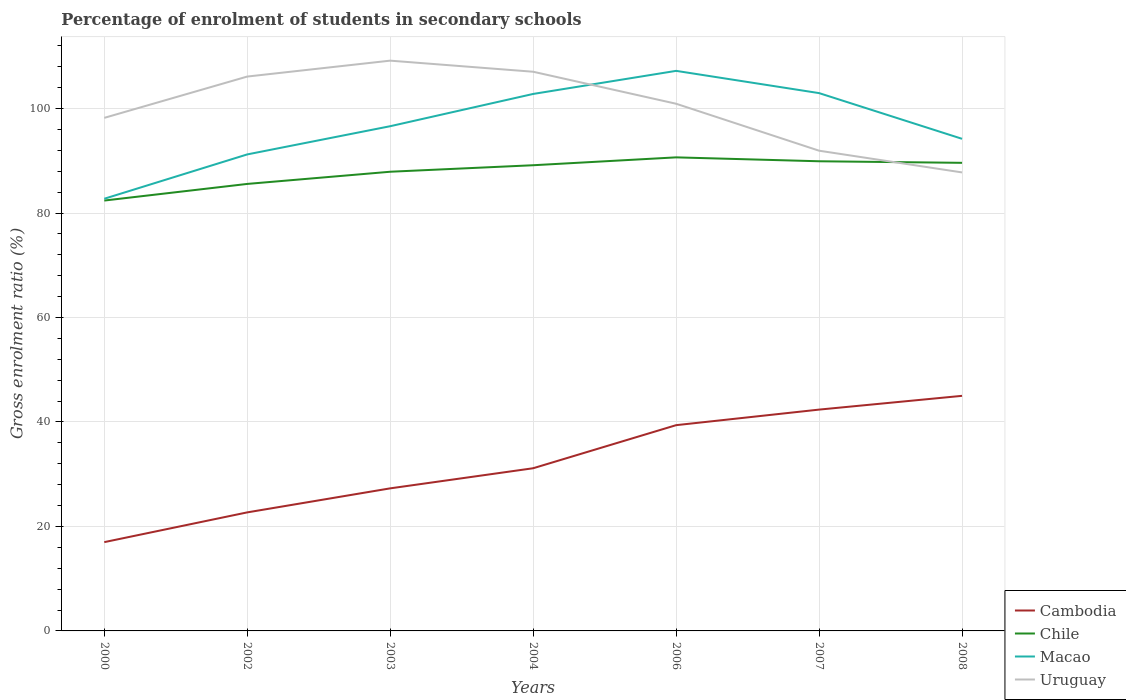Does the line corresponding to Cambodia intersect with the line corresponding to Chile?
Offer a terse response. No. Across all years, what is the maximum percentage of students enrolled in secondary schools in Uruguay?
Offer a terse response. 87.78. What is the total percentage of students enrolled in secondary schools in Uruguay in the graph?
Provide a succinct answer. 19.27. What is the difference between the highest and the second highest percentage of students enrolled in secondary schools in Cambodia?
Offer a very short reply. 28.01. Is the percentage of students enrolled in secondary schools in Macao strictly greater than the percentage of students enrolled in secondary schools in Uruguay over the years?
Your response must be concise. No. How many legend labels are there?
Your response must be concise. 4. How are the legend labels stacked?
Provide a succinct answer. Vertical. What is the title of the graph?
Your response must be concise. Percentage of enrolment of students in secondary schools. Does "Macedonia" appear as one of the legend labels in the graph?
Make the answer very short. No. What is the label or title of the Y-axis?
Make the answer very short. Gross enrolment ratio (%). What is the Gross enrolment ratio (%) in Cambodia in 2000?
Provide a succinct answer. 17. What is the Gross enrolment ratio (%) of Chile in 2000?
Make the answer very short. 82.39. What is the Gross enrolment ratio (%) of Macao in 2000?
Your answer should be compact. 82.74. What is the Gross enrolment ratio (%) of Uruguay in 2000?
Your answer should be compact. 98.22. What is the Gross enrolment ratio (%) in Cambodia in 2002?
Your answer should be very brief. 22.69. What is the Gross enrolment ratio (%) of Chile in 2002?
Provide a short and direct response. 85.58. What is the Gross enrolment ratio (%) of Macao in 2002?
Offer a terse response. 91.23. What is the Gross enrolment ratio (%) of Uruguay in 2002?
Provide a succinct answer. 106.13. What is the Gross enrolment ratio (%) of Cambodia in 2003?
Offer a terse response. 27.29. What is the Gross enrolment ratio (%) of Chile in 2003?
Offer a very short reply. 87.91. What is the Gross enrolment ratio (%) of Macao in 2003?
Make the answer very short. 96.63. What is the Gross enrolment ratio (%) in Uruguay in 2003?
Provide a short and direct response. 109.18. What is the Gross enrolment ratio (%) in Cambodia in 2004?
Your response must be concise. 31.14. What is the Gross enrolment ratio (%) in Chile in 2004?
Provide a succinct answer. 89.15. What is the Gross enrolment ratio (%) in Macao in 2004?
Your answer should be compact. 102.8. What is the Gross enrolment ratio (%) in Uruguay in 2004?
Offer a terse response. 107.05. What is the Gross enrolment ratio (%) of Cambodia in 2006?
Ensure brevity in your answer.  39.39. What is the Gross enrolment ratio (%) of Chile in 2006?
Make the answer very short. 90.66. What is the Gross enrolment ratio (%) in Macao in 2006?
Keep it short and to the point. 107.22. What is the Gross enrolment ratio (%) in Uruguay in 2006?
Ensure brevity in your answer.  100.93. What is the Gross enrolment ratio (%) of Cambodia in 2007?
Provide a succinct answer. 42.37. What is the Gross enrolment ratio (%) of Chile in 2007?
Provide a succinct answer. 89.91. What is the Gross enrolment ratio (%) in Macao in 2007?
Keep it short and to the point. 102.96. What is the Gross enrolment ratio (%) of Uruguay in 2007?
Offer a terse response. 91.94. What is the Gross enrolment ratio (%) of Cambodia in 2008?
Your answer should be very brief. 45.01. What is the Gross enrolment ratio (%) of Chile in 2008?
Your answer should be compact. 89.62. What is the Gross enrolment ratio (%) in Macao in 2008?
Ensure brevity in your answer.  94.21. What is the Gross enrolment ratio (%) in Uruguay in 2008?
Your response must be concise. 87.78. Across all years, what is the maximum Gross enrolment ratio (%) in Cambodia?
Provide a succinct answer. 45.01. Across all years, what is the maximum Gross enrolment ratio (%) in Chile?
Your answer should be compact. 90.66. Across all years, what is the maximum Gross enrolment ratio (%) of Macao?
Offer a terse response. 107.22. Across all years, what is the maximum Gross enrolment ratio (%) in Uruguay?
Make the answer very short. 109.18. Across all years, what is the minimum Gross enrolment ratio (%) in Cambodia?
Provide a succinct answer. 17. Across all years, what is the minimum Gross enrolment ratio (%) in Chile?
Offer a terse response. 82.39. Across all years, what is the minimum Gross enrolment ratio (%) in Macao?
Give a very brief answer. 82.74. Across all years, what is the minimum Gross enrolment ratio (%) of Uruguay?
Provide a succinct answer. 87.78. What is the total Gross enrolment ratio (%) in Cambodia in the graph?
Give a very brief answer. 224.9. What is the total Gross enrolment ratio (%) of Chile in the graph?
Offer a very short reply. 615.23. What is the total Gross enrolment ratio (%) in Macao in the graph?
Keep it short and to the point. 677.79. What is the total Gross enrolment ratio (%) in Uruguay in the graph?
Your response must be concise. 701.23. What is the difference between the Gross enrolment ratio (%) of Cambodia in 2000 and that in 2002?
Make the answer very short. -5.7. What is the difference between the Gross enrolment ratio (%) in Chile in 2000 and that in 2002?
Make the answer very short. -3.18. What is the difference between the Gross enrolment ratio (%) of Macao in 2000 and that in 2002?
Offer a terse response. -8.49. What is the difference between the Gross enrolment ratio (%) in Uruguay in 2000 and that in 2002?
Provide a succinct answer. -7.91. What is the difference between the Gross enrolment ratio (%) of Cambodia in 2000 and that in 2003?
Provide a short and direct response. -10.3. What is the difference between the Gross enrolment ratio (%) in Chile in 2000 and that in 2003?
Give a very brief answer. -5.51. What is the difference between the Gross enrolment ratio (%) of Macao in 2000 and that in 2003?
Keep it short and to the point. -13.89. What is the difference between the Gross enrolment ratio (%) of Uruguay in 2000 and that in 2003?
Give a very brief answer. -10.95. What is the difference between the Gross enrolment ratio (%) in Cambodia in 2000 and that in 2004?
Offer a very short reply. -14.15. What is the difference between the Gross enrolment ratio (%) of Chile in 2000 and that in 2004?
Your response must be concise. -6.76. What is the difference between the Gross enrolment ratio (%) of Macao in 2000 and that in 2004?
Your response must be concise. -20.07. What is the difference between the Gross enrolment ratio (%) in Uruguay in 2000 and that in 2004?
Provide a succinct answer. -8.83. What is the difference between the Gross enrolment ratio (%) of Cambodia in 2000 and that in 2006?
Offer a very short reply. -22.39. What is the difference between the Gross enrolment ratio (%) of Chile in 2000 and that in 2006?
Provide a short and direct response. -8.27. What is the difference between the Gross enrolment ratio (%) in Macao in 2000 and that in 2006?
Provide a short and direct response. -24.48. What is the difference between the Gross enrolment ratio (%) of Uruguay in 2000 and that in 2006?
Keep it short and to the point. -2.7. What is the difference between the Gross enrolment ratio (%) of Cambodia in 2000 and that in 2007?
Offer a very short reply. -25.37. What is the difference between the Gross enrolment ratio (%) of Chile in 2000 and that in 2007?
Offer a very short reply. -7.52. What is the difference between the Gross enrolment ratio (%) of Macao in 2000 and that in 2007?
Your answer should be very brief. -20.23. What is the difference between the Gross enrolment ratio (%) of Uruguay in 2000 and that in 2007?
Make the answer very short. 6.29. What is the difference between the Gross enrolment ratio (%) in Cambodia in 2000 and that in 2008?
Your answer should be very brief. -28.01. What is the difference between the Gross enrolment ratio (%) in Chile in 2000 and that in 2008?
Make the answer very short. -7.22. What is the difference between the Gross enrolment ratio (%) of Macao in 2000 and that in 2008?
Your answer should be very brief. -11.48. What is the difference between the Gross enrolment ratio (%) of Uruguay in 2000 and that in 2008?
Provide a short and direct response. 10.44. What is the difference between the Gross enrolment ratio (%) of Cambodia in 2002 and that in 2003?
Provide a succinct answer. -4.6. What is the difference between the Gross enrolment ratio (%) of Chile in 2002 and that in 2003?
Offer a terse response. -2.33. What is the difference between the Gross enrolment ratio (%) of Macao in 2002 and that in 2003?
Ensure brevity in your answer.  -5.4. What is the difference between the Gross enrolment ratio (%) of Uruguay in 2002 and that in 2003?
Offer a very short reply. -3.04. What is the difference between the Gross enrolment ratio (%) of Cambodia in 2002 and that in 2004?
Keep it short and to the point. -8.45. What is the difference between the Gross enrolment ratio (%) in Chile in 2002 and that in 2004?
Your answer should be compact. -3.58. What is the difference between the Gross enrolment ratio (%) in Macao in 2002 and that in 2004?
Your answer should be very brief. -11.58. What is the difference between the Gross enrolment ratio (%) in Uruguay in 2002 and that in 2004?
Your response must be concise. -0.92. What is the difference between the Gross enrolment ratio (%) of Cambodia in 2002 and that in 2006?
Offer a terse response. -16.7. What is the difference between the Gross enrolment ratio (%) in Chile in 2002 and that in 2006?
Give a very brief answer. -5.09. What is the difference between the Gross enrolment ratio (%) of Macao in 2002 and that in 2006?
Offer a very short reply. -16. What is the difference between the Gross enrolment ratio (%) of Uruguay in 2002 and that in 2006?
Offer a terse response. 5.21. What is the difference between the Gross enrolment ratio (%) of Cambodia in 2002 and that in 2007?
Offer a very short reply. -19.68. What is the difference between the Gross enrolment ratio (%) of Chile in 2002 and that in 2007?
Offer a terse response. -4.34. What is the difference between the Gross enrolment ratio (%) of Macao in 2002 and that in 2007?
Make the answer very short. -11.74. What is the difference between the Gross enrolment ratio (%) of Uruguay in 2002 and that in 2007?
Make the answer very short. 14.2. What is the difference between the Gross enrolment ratio (%) of Cambodia in 2002 and that in 2008?
Ensure brevity in your answer.  -22.31. What is the difference between the Gross enrolment ratio (%) in Chile in 2002 and that in 2008?
Your answer should be compact. -4.04. What is the difference between the Gross enrolment ratio (%) in Macao in 2002 and that in 2008?
Your answer should be compact. -2.99. What is the difference between the Gross enrolment ratio (%) in Uruguay in 2002 and that in 2008?
Give a very brief answer. 18.35. What is the difference between the Gross enrolment ratio (%) of Cambodia in 2003 and that in 2004?
Give a very brief answer. -3.85. What is the difference between the Gross enrolment ratio (%) in Chile in 2003 and that in 2004?
Offer a very short reply. -1.24. What is the difference between the Gross enrolment ratio (%) of Macao in 2003 and that in 2004?
Your answer should be compact. -6.18. What is the difference between the Gross enrolment ratio (%) of Uruguay in 2003 and that in 2004?
Your response must be concise. 2.12. What is the difference between the Gross enrolment ratio (%) in Cambodia in 2003 and that in 2006?
Provide a succinct answer. -12.1. What is the difference between the Gross enrolment ratio (%) in Chile in 2003 and that in 2006?
Make the answer very short. -2.75. What is the difference between the Gross enrolment ratio (%) of Macao in 2003 and that in 2006?
Keep it short and to the point. -10.6. What is the difference between the Gross enrolment ratio (%) in Uruguay in 2003 and that in 2006?
Your answer should be very brief. 8.25. What is the difference between the Gross enrolment ratio (%) in Cambodia in 2003 and that in 2007?
Your response must be concise. -15.08. What is the difference between the Gross enrolment ratio (%) of Chile in 2003 and that in 2007?
Your answer should be very brief. -2. What is the difference between the Gross enrolment ratio (%) in Macao in 2003 and that in 2007?
Your answer should be compact. -6.34. What is the difference between the Gross enrolment ratio (%) of Uruguay in 2003 and that in 2007?
Offer a very short reply. 17.24. What is the difference between the Gross enrolment ratio (%) in Cambodia in 2003 and that in 2008?
Your answer should be compact. -17.71. What is the difference between the Gross enrolment ratio (%) of Chile in 2003 and that in 2008?
Your answer should be very brief. -1.71. What is the difference between the Gross enrolment ratio (%) of Macao in 2003 and that in 2008?
Keep it short and to the point. 2.41. What is the difference between the Gross enrolment ratio (%) of Uruguay in 2003 and that in 2008?
Offer a very short reply. 21.4. What is the difference between the Gross enrolment ratio (%) of Cambodia in 2004 and that in 2006?
Provide a short and direct response. -8.25. What is the difference between the Gross enrolment ratio (%) of Chile in 2004 and that in 2006?
Your answer should be compact. -1.51. What is the difference between the Gross enrolment ratio (%) of Macao in 2004 and that in 2006?
Your response must be concise. -4.42. What is the difference between the Gross enrolment ratio (%) of Uruguay in 2004 and that in 2006?
Ensure brevity in your answer.  6.13. What is the difference between the Gross enrolment ratio (%) in Cambodia in 2004 and that in 2007?
Make the answer very short. -11.23. What is the difference between the Gross enrolment ratio (%) in Chile in 2004 and that in 2007?
Make the answer very short. -0.76. What is the difference between the Gross enrolment ratio (%) of Macao in 2004 and that in 2007?
Offer a very short reply. -0.16. What is the difference between the Gross enrolment ratio (%) of Uruguay in 2004 and that in 2007?
Give a very brief answer. 15.12. What is the difference between the Gross enrolment ratio (%) of Cambodia in 2004 and that in 2008?
Keep it short and to the point. -13.86. What is the difference between the Gross enrolment ratio (%) in Chile in 2004 and that in 2008?
Your answer should be compact. -0.46. What is the difference between the Gross enrolment ratio (%) of Macao in 2004 and that in 2008?
Your answer should be very brief. 8.59. What is the difference between the Gross enrolment ratio (%) of Uruguay in 2004 and that in 2008?
Your response must be concise. 19.27. What is the difference between the Gross enrolment ratio (%) in Cambodia in 2006 and that in 2007?
Offer a terse response. -2.98. What is the difference between the Gross enrolment ratio (%) in Chile in 2006 and that in 2007?
Keep it short and to the point. 0.75. What is the difference between the Gross enrolment ratio (%) in Macao in 2006 and that in 2007?
Your answer should be compact. 4.26. What is the difference between the Gross enrolment ratio (%) of Uruguay in 2006 and that in 2007?
Keep it short and to the point. 8.99. What is the difference between the Gross enrolment ratio (%) in Cambodia in 2006 and that in 2008?
Make the answer very short. -5.62. What is the difference between the Gross enrolment ratio (%) in Chile in 2006 and that in 2008?
Make the answer very short. 1.05. What is the difference between the Gross enrolment ratio (%) of Macao in 2006 and that in 2008?
Your response must be concise. 13.01. What is the difference between the Gross enrolment ratio (%) in Uruguay in 2006 and that in 2008?
Give a very brief answer. 13.15. What is the difference between the Gross enrolment ratio (%) of Cambodia in 2007 and that in 2008?
Offer a very short reply. -2.64. What is the difference between the Gross enrolment ratio (%) in Chile in 2007 and that in 2008?
Offer a very short reply. 0.3. What is the difference between the Gross enrolment ratio (%) of Macao in 2007 and that in 2008?
Offer a very short reply. 8.75. What is the difference between the Gross enrolment ratio (%) in Uruguay in 2007 and that in 2008?
Provide a short and direct response. 4.16. What is the difference between the Gross enrolment ratio (%) in Cambodia in 2000 and the Gross enrolment ratio (%) in Chile in 2002?
Offer a very short reply. -68.58. What is the difference between the Gross enrolment ratio (%) of Cambodia in 2000 and the Gross enrolment ratio (%) of Macao in 2002?
Make the answer very short. -74.23. What is the difference between the Gross enrolment ratio (%) in Cambodia in 2000 and the Gross enrolment ratio (%) in Uruguay in 2002?
Your answer should be very brief. -89.13. What is the difference between the Gross enrolment ratio (%) in Chile in 2000 and the Gross enrolment ratio (%) in Macao in 2002?
Provide a succinct answer. -8.83. What is the difference between the Gross enrolment ratio (%) of Chile in 2000 and the Gross enrolment ratio (%) of Uruguay in 2002?
Give a very brief answer. -23.74. What is the difference between the Gross enrolment ratio (%) of Macao in 2000 and the Gross enrolment ratio (%) of Uruguay in 2002?
Offer a terse response. -23.4. What is the difference between the Gross enrolment ratio (%) in Cambodia in 2000 and the Gross enrolment ratio (%) in Chile in 2003?
Provide a succinct answer. -70.91. What is the difference between the Gross enrolment ratio (%) in Cambodia in 2000 and the Gross enrolment ratio (%) in Macao in 2003?
Give a very brief answer. -79.63. What is the difference between the Gross enrolment ratio (%) of Cambodia in 2000 and the Gross enrolment ratio (%) of Uruguay in 2003?
Ensure brevity in your answer.  -92.18. What is the difference between the Gross enrolment ratio (%) in Chile in 2000 and the Gross enrolment ratio (%) in Macao in 2003?
Your answer should be very brief. -14.23. What is the difference between the Gross enrolment ratio (%) in Chile in 2000 and the Gross enrolment ratio (%) in Uruguay in 2003?
Give a very brief answer. -26.78. What is the difference between the Gross enrolment ratio (%) in Macao in 2000 and the Gross enrolment ratio (%) in Uruguay in 2003?
Keep it short and to the point. -26.44. What is the difference between the Gross enrolment ratio (%) of Cambodia in 2000 and the Gross enrolment ratio (%) of Chile in 2004?
Give a very brief answer. -72.16. What is the difference between the Gross enrolment ratio (%) of Cambodia in 2000 and the Gross enrolment ratio (%) of Macao in 2004?
Offer a terse response. -85.8. What is the difference between the Gross enrolment ratio (%) of Cambodia in 2000 and the Gross enrolment ratio (%) of Uruguay in 2004?
Your response must be concise. -90.06. What is the difference between the Gross enrolment ratio (%) of Chile in 2000 and the Gross enrolment ratio (%) of Macao in 2004?
Make the answer very short. -20.41. What is the difference between the Gross enrolment ratio (%) in Chile in 2000 and the Gross enrolment ratio (%) in Uruguay in 2004?
Your answer should be very brief. -24.66. What is the difference between the Gross enrolment ratio (%) in Macao in 2000 and the Gross enrolment ratio (%) in Uruguay in 2004?
Your answer should be compact. -24.32. What is the difference between the Gross enrolment ratio (%) of Cambodia in 2000 and the Gross enrolment ratio (%) of Chile in 2006?
Give a very brief answer. -73.66. What is the difference between the Gross enrolment ratio (%) in Cambodia in 2000 and the Gross enrolment ratio (%) in Macao in 2006?
Your answer should be compact. -90.22. What is the difference between the Gross enrolment ratio (%) in Cambodia in 2000 and the Gross enrolment ratio (%) in Uruguay in 2006?
Offer a very short reply. -83.93. What is the difference between the Gross enrolment ratio (%) in Chile in 2000 and the Gross enrolment ratio (%) in Macao in 2006?
Make the answer very short. -24.83. What is the difference between the Gross enrolment ratio (%) of Chile in 2000 and the Gross enrolment ratio (%) of Uruguay in 2006?
Your answer should be very brief. -18.53. What is the difference between the Gross enrolment ratio (%) in Macao in 2000 and the Gross enrolment ratio (%) in Uruguay in 2006?
Provide a short and direct response. -18.19. What is the difference between the Gross enrolment ratio (%) in Cambodia in 2000 and the Gross enrolment ratio (%) in Chile in 2007?
Provide a short and direct response. -72.92. What is the difference between the Gross enrolment ratio (%) in Cambodia in 2000 and the Gross enrolment ratio (%) in Macao in 2007?
Keep it short and to the point. -85.97. What is the difference between the Gross enrolment ratio (%) in Cambodia in 2000 and the Gross enrolment ratio (%) in Uruguay in 2007?
Your answer should be compact. -74.94. What is the difference between the Gross enrolment ratio (%) of Chile in 2000 and the Gross enrolment ratio (%) of Macao in 2007?
Provide a succinct answer. -20.57. What is the difference between the Gross enrolment ratio (%) in Chile in 2000 and the Gross enrolment ratio (%) in Uruguay in 2007?
Make the answer very short. -9.54. What is the difference between the Gross enrolment ratio (%) in Macao in 2000 and the Gross enrolment ratio (%) in Uruguay in 2007?
Make the answer very short. -9.2. What is the difference between the Gross enrolment ratio (%) in Cambodia in 2000 and the Gross enrolment ratio (%) in Chile in 2008?
Your answer should be very brief. -72.62. What is the difference between the Gross enrolment ratio (%) of Cambodia in 2000 and the Gross enrolment ratio (%) of Macao in 2008?
Make the answer very short. -77.22. What is the difference between the Gross enrolment ratio (%) of Cambodia in 2000 and the Gross enrolment ratio (%) of Uruguay in 2008?
Make the answer very short. -70.78. What is the difference between the Gross enrolment ratio (%) in Chile in 2000 and the Gross enrolment ratio (%) in Macao in 2008?
Your answer should be very brief. -11.82. What is the difference between the Gross enrolment ratio (%) in Chile in 2000 and the Gross enrolment ratio (%) in Uruguay in 2008?
Provide a short and direct response. -5.38. What is the difference between the Gross enrolment ratio (%) in Macao in 2000 and the Gross enrolment ratio (%) in Uruguay in 2008?
Keep it short and to the point. -5.04. What is the difference between the Gross enrolment ratio (%) of Cambodia in 2002 and the Gross enrolment ratio (%) of Chile in 2003?
Keep it short and to the point. -65.22. What is the difference between the Gross enrolment ratio (%) in Cambodia in 2002 and the Gross enrolment ratio (%) in Macao in 2003?
Offer a terse response. -73.93. What is the difference between the Gross enrolment ratio (%) of Cambodia in 2002 and the Gross enrolment ratio (%) of Uruguay in 2003?
Your answer should be very brief. -86.48. What is the difference between the Gross enrolment ratio (%) in Chile in 2002 and the Gross enrolment ratio (%) in Macao in 2003?
Your response must be concise. -11.05. What is the difference between the Gross enrolment ratio (%) in Chile in 2002 and the Gross enrolment ratio (%) in Uruguay in 2003?
Ensure brevity in your answer.  -23.6. What is the difference between the Gross enrolment ratio (%) of Macao in 2002 and the Gross enrolment ratio (%) of Uruguay in 2003?
Your answer should be very brief. -17.95. What is the difference between the Gross enrolment ratio (%) in Cambodia in 2002 and the Gross enrolment ratio (%) in Chile in 2004?
Ensure brevity in your answer.  -66.46. What is the difference between the Gross enrolment ratio (%) in Cambodia in 2002 and the Gross enrolment ratio (%) in Macao in 2004?
Offer a very short reply. -80.11. What is the difference between the Gross enrolment ratio (%) in Cambodia in 2002 and the Gross enrolment ratio (%) in Uruguay in 2004?
Your answer should be very brief. -84.36. What is the difference between the Gross enrolment ratio (%) in Chile in 2002 and the Gross enrolment ratio (%) in Macao in 2004?
Provide a succinct answer. -17.23. What is the difference between the Gross enrolment ratio (%) in Chile in 2002 and the Gross enrolment ratio (%) in Uruguay in 2004?
Your answer should be very brief. -21.48. What is the difference between the Gross enrolment ratio (%) in Macao in 2002 and the Gross enrolment ratio (%) in Uruguay in 2004?
Ensure brevity in your answer.  -15.83. What is the difference between the Gross enrolment ratio (%) of Cambodia in 2002 and the Gross enrolment ratio (%) of Chile in 2006?
Keep it short and to the point. -67.97. What is the difference between the Gross enrolment ratio (%) in Cambodia in 2002 and the Gross enrolment ratio (%) in Macao in 2006?
Your answer should be very brief. -84.53. What is the difference between the Gross enrolment ratio (%) of Cambodia in 2002 and the Gross enrolment ratio (%) of Uruguay in 2006?
Provide a succinct answer. -78.23. What is the difference between the Gross enrolment ratio (%) of Chile in 2002 and the Gross enrolment ratio (%) of Macao in 2006?
Give a very brief answer. -21.65. What is the difference between the Gross enrolment ratio (%) in Chile in 2002 and the Gross enrolment ratio (%) in Uruguay in 2006?
Your response must be concise. -15.35. What is the difference between the Gross enrolment ratio (%) of Macao in 2002 and the Gross enrolment ratio (%) of Uruguay in 2006?
Provide a succinct answer. -9.7. What is the difference between the Gross enrolment ratio (%) in Cambodia in 2002 and the Gross enrolment ratio (%) in Chile in 2007?
Offer a very short reply. -67.22. What is the difference between the Gross enrolment ratio (%) in Cambodia in 2002 and the Gross enrolment ratio (%) in Macao in 2007?
Give a very brief answer. -80.27. What is the difference between the Gross enrolment ratio (%) in Cambodia in 2002 and the Gross enrolment ratio (%) in Uruguay in 2007?
Your answer should be compact. -69.24. What is the difference between the Gross enrolment ratio (%) of Chile in 2002 and the Gross enrolment ratio (%) of Macao in 2007?
Provide a succinct answer. -17.39. What is the difference between the Gross enrolment ratio (%) of Chile in 2002 and the Gross enrolment ratio (%) of Uruguay in 2007?
Your answer should be compact. -6.36. What is the difference between the Gross enrolment ratio (%) of Macao in 2002 and the Gross enrolment ratio (%) of Uruguay in 2007?
Provide a short and direct response. -0.71. What is the difference between the Gross enrolment ratio (%) in Cambodia in 2002 and the Gross enrolment ratio (%) in Chile in 2008?
Give a very brief answer. -66.92. What is the difference between the Gross enrolment ratio (%) of Cambodia in 2002 and the Gross enrolment ratio (%) of Macao in 2008?
Offer a very short reply. -71.52. What is the difference between the Gross enrolment ratio (%) in Cambodia in 2002 and the Gross enrolment ratio (%) in Uruguay in 2008?
Your response must be concise. -65.08. What is the difference between the Gross enrolment ratio (%) in Chile in 2002 and the Gross enrolment ratio (%) in Macao in 2008?
Offer a very short reply. -8.64. What is the difference between the Gross enrolment ratio (%) of Chile in 2002 and the Gross enrolment ratio (%) of Uruguay in 2008?
Make the answer very short. -2.2. What is the difference between the Gross enrolment ratio (%) in Macao in 2002 and the Gross enrolment ratio (%) in Uruguay in 2008?
Keep it short and to the point. 3.45. What is the difference between the Gross enrolment ratio (%) of Cambodia in 2003 and the Gross enrolment ratio (%) of Chile in 2004?
Your response must be concise. -61.86. What is the difference between the Gross enrolment ratio (%) of Cambodia in 2003 and the Gross enrolment ratio (%) of Macao in 2004?
Provide a short and direct response. -75.51. What is the difference between the Gross enrolment ratio (%) of Cambodia in 2003 and the Gross enrolment ratio (%) of Uruguay in 2004?
Offer a very short reply. -79.76. What is the difference between the Gross enrolment ratio (%) of Chile in 2003 and the Gross enrolment ratio (%) of Macao in 2004?
Provide a succinct answer. -14.89. What is the difference between the Gross enrolment ratio (%) in Chile in 2003 and the Gross enrolment ratio (%) in Uruguay in 2004?
Your answer should be compact. -19.14. What is the difference between the Gross enrolment ratio (%) of Macao in 2003 and the Gross enrolment ratio (%) of Uruguay in 2004?
Provide a short and direct response. -10.43. What is the difference between the Gross enrolment ratio (%) in Cambodia in 2003 and the Gross enrolment ratio (%) in Chile in 2006?
Your answer should be very brief. -63.37. What is the difference between the Gross enrolment ratio (%) in Cambodia in 2003 and the Gross enrolment ratio (%) in Macao in 2006?
Make the answer very short. -79.93. What is the difference between the Gross enrolment ratio (%) of Cambodia in 2003 and the Gross enrolment ratio (%) of Uruguay in 2006?
Make the answer very short. -73.63. What is the difference between the Gross enrolment ratio (%) of Chile in 2003 and the Gross enrolment ratio (%) of Macao in 2006?
Ensure brevity in your answer.  -19.31. What is the difference between the Gross enrolment ratio (%) of Chile in 2003 and the Gross enrolment ratio (%) of Uruguay in 2006?
Your response must be concise. -13.02. What is the difference between the Gross enrolment ratio (%) of Macao in 2003 and the Gross enrolment ratio (%) of Uruguay in 2006?
Your answer should be very brief. -4.3. What is the difference between the Gross enrolment ratio (%) of Cambodia in 2003 and the Gross enrolment ratio (%) of Chile in 2007?
Your answer should be compact. -62.62. What is the difference between the Gross enrolment ratio (%) in Cambodia in 2003 and the Gross enrolment ratio (%) in Macao in 2007?
Keep it short and to the point. -75.67. What is the difference between the Gross enrolment ratio (%) of Cambodia in 2003 and the Gross enrolment ratio (%) of Uruguay in 2007?
Your answer should be very brief. -64.64. What is the difference between the Gross enrolment ratio (%) of Chile in 2003 and the Gross enrolment ratio (%) of Macao in 2007?
Your response must be concise. -15.05. What is the difference between the Gross enrolment ratio (%) in Chile in 2003 and the Gross enrolment ratio (%) in Uruguay in 2007?
Keep it short and to the point. -4.03. What is the difference between the Gross enrolment ratio (%) of Macao in 2003 and the Gross enrolment ratio (%) of Uruguay in 2007?
Your answer should be very brief. 4.69. What is the difference between the Gross enrolment ratio (%) in Cambodia in 2003 and the Gross enrolment ratio (%) in Chile in 2008?
Your answer should be very brief. -62.32. What is the difference between the Gross enrolment ratio (%) in Cambodia in 2003 and the Gross enrolment ratio (%) in Macao in 2008?
Offer a very short reply. -66.92. What is the difference between the Gross enrolment ratio (%) of Cambodia in 2003 and the Gross enrolment ratio (%) of Uruguay in 2008?
Your response must be concise. -60.48. What is the difference between the Gross enrolment ratio (%) of Chile in 2003 and the Gross enrolment ratio (%) of Macao in 2008?
Make the answer very short. -6.3. What is the difference between the Gross enrolment ratio (%) in Chile in 2003 and the Gross enrolment ratio (%) in Uruguay in 2008?
Ensure brevity in your answer.  0.13. What is the difference between the Gross enrolment ratio (%) of Macao in 2003 and the Gross enrolment ratio (%) of Uruguay in 2008?
Make the answer very short. 8.85. What is the difference between the Gross enrolment ratio (%) of Cambodia in 2004 and the Gross enrolment ratio (%) of Chile in 2006?
Offer a very short reply. -59.52. What is the difference between the Gross enrolment ratio (%) of Cambodia in 2004 and the Gross enrolment ratio (%) of Macao in 2006?
Provide a succinct answer. -76.08. What is the difference between the Gross enrolment ratio (%) of Cambodia in 2004 and the Gross enrolment ratio (%) of Uruguay in 2006?
Give a very brief answer. -69.78. What is the difference between the Gross enrolment ratio (%) of Chile in 2004 and the Gross enrolment ratio (%) of Macao in 2006?
Ensure brevity in your answer.  -18.07. What is the difference between the Gross enrolment ratio (%) of Chile in 2004 and the Gross enrolment ratio (%) of Uruguay in 2006?
Offer a terse response. -11.77. What is the difference between the Gross enrolment ratio (%) in Macao in 2004 and the Gross enrolment ratio (%) in Uruguay in 2006?
Make the answer very short. 1.88. What is the difference between the Gross enrolment ratio (%) of Cambodia in 2004 and the Gross enrolment ratio (%) of Chile in 2007?
Give a very brief answer. -58.77. What is the difference between the Gross enrolment ratio (%) of Cambodia in 2004 and the Gross enrolment ratio (%) of Macao in 2007?
Your answer should be very brief. -71.82. What is the difference between the Gross enrolment ratio (%) of Cambodia in 2004 and the Gross enrolment ratio (%) of Uruguay in 2007?
Offer a very short reply. -60.79. What is the difference between the Gross enrolment ratio (%) of Chile in 2004 and the Gross enrolment ratio (%) of Macao in 2007?
Keep it short and to the point. -13.81. What is the difference between the Gross enrolment ratio (%) of Chile in 2004 and the Gross enrolment ratio (%) of Uruguay in 2007?
Keep it short and to the point. -2.78. What is the difference between the Gross enrolment ratio (%) of Macao in 2004 and the Gross enrolment ratio (%) of Uruguay in 2007?
Provide a succinct answer. 10.87. What is the difference between the Gross enrolment ratio (%) in Cambodia in 2004 and the Gross enrolment ratio (%) in Chile in 2008?
Give a very brief answer. -58.47. What is the difference between the Gross enrolment ratio (%) in Cambodia in 2004 and the Gross enrolment ratio (%) in Macao in 2008?
Provide a short and direct response. -63.07. What is the difference between the Gross enrolment ratio (%) in Cambodia in 2004 and the Gross enrolment ratio (%) in Uruguay in 2008?
Make the answer very short. -56.63. What is the difference between the Gross enrolment ratio (%) in Chile in 2004 and the Gross enrolment ratio (%) in Macao in 2008?
Offer a very short reply. -5.06. What is the difference between the Gross enrolment ratio (%) in Chile in 2004 and the Gross enrolment ratio (%) in Uruguay in 2008?
Your answer should be very brief. 1.38. What is the difference between the Gross enrolment ratio (%) in Macao in 2004 and the Gross enrolment ratio (%) in Uruguay in 2008?
Your response must be concise. 15.02. What is the difference between the Gross enrolment ratio (%) of Cambodia in 2006 and the Gross enrolment ratio (%) of Chile in 2007?
Provide a short and direct response. -50.52. What is the difference between the Gross enrolment ratio (%) of Cambodia in 2006 and the Gross enrolment ratio (%) of Macao in 2007?
Provide a short and direct response. -63.57. What is the difference between the Gross enrolment ratio (%) of Cambodia in 2006 and the Gross enrolment ratio (%) of Uruguay in 2007?
Offer a very short reply. -52.55. What is the difference between the Gross enrolment ratio (%) in Chile in 2006 and the Gross enrolment ratio (%) in Macao in 2007?
Your answer should be compact. -12.3. What is the difference between the Gross enrolment ratio (%) in Chile in 2006 and the Gross enrolment ratio (%) in Uruguay in 2007?
Offer a terse response. -1.27. What is the difference between the Gross enrolment ratio (%) in Macao in 2006 and the Gross enrolment ratio (%) in Uruguay in 2007?
Your response must be concise. 15.29. What is the difference between the Gross enrolment ratio (%) in Cambodia in 2006 and the Gross enrolment ratio (%) in Chile in 2008?
Your answer should be compact. -50.22. What is the difference between the Gross enrolment ratio (%) in Cambodia in 2006 and the Gross enrolment ratio (%) in Macao in 2008?
Your answer should be very brief. -54.82. What is the difference between the Gross enrolment ratio (%) in Cambodia in 2006 and the Gross enrolment ratio (%) in Uruguay in 2008?
Your response must be concise. -48.39. What is the difference between the Gross enrolment ratio (%) of Chile in 2006 and the Gross enrolment ratio (%) of Macao in 2008?
Ensure brevity in your answer.  -3.55. What is the difference between the Gross enrolment ratio (%) in Chile in 2006 and the Gross enrolment ratio (%) in Uruguay in 2008?
Give a very brief answer. 2.88. What is the difference between the Gross enrolment ratio (%) of Macao in 2006 and the Gross enrolment ratio (%) of Uruguay in 2008?
Offer a terse response. 19.44. What is the difference between the Gross enrolment ratio (%) of Cambodia in 2007 and the Gross enrolment ratio (%) of Chile in 2008?
Your response must be concise. -47.25. What is the difference between the Gross enrolment ratio (%) of Cambodia in 2007 and the Gross enrolment ratio (%) of Macao in 2008?
Your answer should be very brief. -51.84. What is the difference between the Gross enrolment ratio (%) of Cambodia in 2007 and the Gross enrolment ratio (%) of Uruguay in 2008?
Give a very brief answer. -45.41. What is the difference between the Gross enrolment ratio (%) of Chile in 2007 and the Gross enrolment ratio (%) of Macao in 2008?
Keep it short and to the point. -4.3. What is the difference between the Gross enrolment ratio (%) of Chile in 2007 and the Gross enrolment ratio (%) of Uruguay in 2008?
Your answer should be compact. 2.13. What is the difference between the Gross enrolment ratio (%) of Macao in 2007 and the Gross enrolment ratio (%) of Uruguay in 2008?
Provide a succinct answer. 15.18. What is the average Gross enrolment ratio (%) of Cambodia per year?
Give a very brief answer. 32.13. What is the average Gross enrolment ratio (%) in Chile per year?
Provide a succinct answer. 87.89. What is the average Gross enrolment ratio (%) of Macao per year?
Your answer should be very brief. 96.83. What is the average Gross enrolment ratio (%) of Uruguay per year?
Your answer should be very brief. 100.18. In the year 2000, what is the difference between the Gross enrolment ratio (%) in Cambodia and Gross enrolment ratio (%) in Chile?
Give a very brief answer. -65.4. In the year 2000, what is the difference between the Gross enrolment ratio (%) of Cambodia and Gross enrolment ratio (%) of Macao?
Keep it short and to the point. -65.74. In the year 2000, what is the difference between the Gross enrolment ratio (%) of Cambodia and Gross enrolment ratio (%) of Uruguay?
Keep it short and to the point. -81.22. In the year 2000, what is the difference between the Gross enrolment ratio (%) of Chile and Gross enrolment ratio (%) of Macao?
Keep it short and to the point. -0.34. In the year 2000, what is the difference between the Gross enrolment ratio (%) in Chile and Gross enrolment ratio (%) in Uruguay?
Give a very brief answer. -15.83. In the year 2000, what is the difference between the Gross enrolment ratio (%) of Macao and Gross enrolment ratio (%) of Uruguay?
Ensure brevity in your answer.  -15.49. In the year 2002, what is the difference between the Gross enrolment ratio (%) in Cambodia and Gross enrolment ratio (%) in Chile?
Offer a very short reply. -62.88. In the year 2002, what is the difference between the Gross enrolment ratio (%) of Cambodia and Gross enrolment ratio (%) of Macao?
Give a very brief answer. -68.53. In the year 2002, what is the difference between the Gross enrolment ratio (%) in Cambodia and Gross enrolment ratio (%) in Uruguay?
Offer a terse response. -83.44. In the year 2002, what is the difference between the Gross enrolment ratio (%) of Chile and Gross enrolment ratio (%) of Macao?
Provide a short and direct response. -5.65. In the year 2002, what is the difference between the Gross enrolment ratio (%) of Chile and Gross enrolment ratio (%) of Uruguay?
Keep it short and to the point. -20.56. In the year 2002, what is the difference between the Gross enrolment ratio (%) in Macao and Gross enrolment ratio (%) in Uruguay?
Make the answer very short. -14.91. In the year 2003, what is the difference between the Gross enrolment ratio (%) of Cambodia and Gross enrolment ratio (%) of Chile?
Your response must be concise. -60.61. In the year 2003, what is the difference between the Gross enrolment ratio (%) of Cambodia and Gross enrolment ratio (%) of Macao?
Make the answer very short. -69.33. In the year 2003, what is the difference between the Gross enrolment ratio (%) in Cambodia and Gross enrolment ratio (%) in Uruguay?
Offer a terse response. -81.88. In the year 2003, what is the difference between the Gross enrolment ratio (%) of Chile and Gross enrolment ratio (%) of Macao?
Your response must be concise. -8.72. In the year 2003, what is the difference between the Gross enrolment ratio (%) in Chile and Gross enrolment ratio (%) in Uruguay?
Keep it short and to the point. -21.27. In the year 2003, what is the difference between the Gross enrolment ratio (%) of Macao and Gross enrolment ratio (%) of Uruguay?
Ensure brevity in your answer.  -12.55. In the year 2004, what is the difference between the Gross enrolment ratio (%) of Cambodia and Gross enrolment ratio (%) of Chile?
Give a very brief answer. -58.01. In the year 2004, what is the difference between the Gross enrolment ratio (%) in Cambodia and Gross enrolment ratio (%) in Macao?
Your answer should be very brief. -71.66. In the year 2004, what is the difference between the Gross enrolment ratio (%) in Cambodia and Gross enrolment ratio (%) in Uruguay?
Keep it short and to the point. -75.91. In the year 2004, what is the difference between the Gross enrolment ratio (%) of Chile and Gross enrolment ratio (%) of Macao?
Your answer should be very brief. -13.65. In the year 2004, what is the difference between the Gross enrolment ratio (%) of Chile and Gross enrolment ratio (%) of Uruguay?
Provide a short and direct response. -17.9. In the year 2004, what is the difference between the Gross enrolment ratio (%) in Macao and Gross enrolment ratio (%) in Uruguay?
Keep it short and to the point. -4.25. In the year 2006, what is the difference between the Gross enrolment ratio (%) of Cambodia and Gross enrolment ratio (%) of Chile?
Offer a very short reply. -51.27. In the year 2006, what is the difference between the Gross enrolment ratio (%) of Cambodia and Gross enrolment ratio (%) of Macao?
Offer a terse response. -67.83. In the year 2006, what is the difference between the Gross enrolment ratio (%) of Cambodia and Gross enrolment ratio (%) of Uruguay?
Your answer should be compact. -61.54. In the year 2006, what is the difference between the Gross enrolment ratio (%) of Chile and Gross enrolment ratio (%) of Macao?
Your answer should be compact. -16.56. In the year 2006, what is the difference between the Gross enrolment ratio (%) in Chile and Gross enrolment ratio (%) in Uruguay?
Offer a very short reply. -10.26. In the year 2006, what is the difference between the Gross enrolment ratio (%) of Macao and Gross enrolment ratio (%) of Uruguay?
Make the answer very short. 6.3. In the year 2007, what is the difference between the Gross enrolment ratio (%) in Cambodia and Gross enrolment ratio (%) in Chile?
Give a very brief answer. -47.54. In the year 2007, what is the difference between the Gross enrolment ratio (%) of Cambodia and Gross enrolment ratio (%) of Macao?
Provide a succinct answer. -60.59. In the year 2007, what is the difference between the Gross enrolment ratio (%) of Cambodia and Gross enrolment ratio (%) of Uruguay?
Give a very brief answer. -49.57. In the year 2007, what is the difference between the Gross enrolment ratio (%) in Chile and Gross enrolment ratio (%) in Macao?
Ensure brevity in your answer.  -13.05. In the year 2007, what is the difference between the Gross enrolment ratio (%) of Chile and Gross enrolment ratio (%) of Uruguay?
Offer a terse response. -2.02. In the year 2007, what is the difference between the Gross enrolment ratio (%) in Macao and Gross enrolment ratio (%) in Uruguay?
Provide a succinct answer. 11.03. In the year 2008, what is the difference between the Gross enrolment ratio (%) in Cambodia and Gross enrolment ratio (%) in Chile?
Keep it short and to the point. -44.61. In the year 2008, what is the difference between the Gross enrolment ratio (%) of Cambodia and Gross enrolment ratio (%) of Macao?
Make the answer very short. -49.21. In the year 2008, what is the difference between the Gross enrolment ratio (%) in Cambodia and Gross enrolment ratio (%) in Uruguay?
Offer a terse response. -42.77. In the year 2008, what is the difference between the Gross enrolment ratio (%) of Chile and Gross enrolment ratio (%) of Macao?
Provide a succinct answer. -4.6. In the year 2008, what is the difference between the Gross enrolment ratio (%) in Chile and Gross enrolment ratio (%) in Uruguay?
Give a very brief answer. 1.84. In the year 2008, what is the difference between the Gross enrolment ratio (%) in Macao and Gross enrolment ratio (%) in Uruguay?
Provide a short and direct response. 6.43. What is the ratio of the Gross enrolment ratio (%) in Cambodia in 2000 to that in 2002?
Give a very brief answer. 0.75. What is the ratio of the Gross enrolment ratio (%) in Chile in 2000 to that in 2002?
Your answer should be compact. 0.96. What is the ratio of the Gross enrolment ratio (%) of Macao in 2000 to that in 2002?
Give a very brief answer. 0.91. What is the ratio of the Gross enrolment ratio (%) in Uruguay in 2000 to that in 2002?
Offer a terse response. 0.93. What is the ratio of the Gross enrolment ratio (%) in Cambodia in 2000 to that in 2003?
Provide a short and direct response. 0.62. What is the ratio of the Gross enrolment ratio (%) in Chile in 2000 to that in 2003?
Ensure brevity in your answer.  0.94. What is the ratio of the Gross enrolment ratio (%) of Macao in 2000 to that in 2003?
Keep it short and to the point. 0.86. What is the ratio of the Gross enrolment ratio (%) in Uruguay in 2000 to that in 2003?
Your answer should be very brief. 0.9. What is the ratio of the Gross enrolment ratio (%) in Cambodia in 2000 to that in 2004?
Your answer should be very brief. 0.55. What is the ratio of the Gross enrolment ratio (%) in Chile in 2000 to that in 2004?
Your response must be concise. 0.92. What is the ratio of the Gross enrolment ratio (%) in Macao in 2000 to that in 2004?
Your answer should be compact. 0.8. What is the ratio of the Gross enrolment ratio (%) of Uruguay in 2000 to that in 2004?
Make the answer very short. 0.92. What is the ratio of the Gross enrolment ratio (%) in Cambodia in 2000 to that in 2006?
Your response must be concise. 0.43. What is the ratio of the Gross enrolment ratio (%) in Chile in 2000 to that in 2006?
Provide a succinct answer. 0.91. What is the ratio of the Gross enrolment ratio (%) of Macao in 2000 to that in 2006?
Offer a very short reply. 0.77. What is the ratio of the Gross enrolment ratio (%) in Uruguay in 2000 to that in 2006?
Give a very brief answer. 0.97. What is the ratio of the Gross enrolment ratio (%) of Cambodia in 2000 to that in 2007?
Make the answer very short. 0.4. What is the ratio of the Gross enrolment ratio (%) of Chile in 2000 to that in 2007?
Keep it short and to the point. 0.92. What is the ratio of the Gross enrolment ratio (%) in Macao in 2000 to that in 2007?
Offer a very short reply. 0.8. What is the ratio of the Gross enrolment ratio (%) of Uruguay in 2000 to that in 2007?
Your answer should be very brief. 1.07. What is the ratio of the Gross enrolment ratio (%) of Cambodia in 2000 to that in 2008?
Provide a succinct answer. 0.38. What is the ratio of the Gross enrolment ratio (%) in Chile in 2000 to that in 2008?
Your response must be concise. 0.92. What is the ratio of the Gross enrolment ratio (%) in Macao in 2000 to that in 2008?
Give a very brief answer. 0.88. What is the ratio of the Gross enrolment ratio (%) in Uruguay in 2000 to that in 2008?
Offer a very short reply. 1.12. What is the ratio of the Gross enrolment ratio (%) of Cambodia in 2002 to that in 2003?
Provide a succinct answer. 0.83. What is the ratio of the Gross enrolment ratio (%) in Chile in 2002 to that in 2003?
Give a very brief answer. 0.97. What is the ratio of the Gross enrolment ratio (%) of Macao in 2002 to that in 2003?
Offer a very short reply. 0.94. What is the ratio of the Gross enrolment ratio (%) in Uruguay in 2002 to that in 2003?
Your answer should be compact. 0.97. What is the ratio of the Gross enrolment ratio (%) of Cambodia in 2002 to that in 2004?
Provide a short and direct response. 0.73. What is the ratio of the Gross enrolment ratio (%) of Chile in 2002 to that in 2004?
Your answer should be very brief. 0.96. What is the ratio of the Gross enrolment ratio (%) in Macao in 2002 to that in 2004?
Your response must be concise. 0.89. What is the ratio of the Gross enrolment ratio (%) in Cambodia in 2002 to that in 2006?
Your response must be concise. 0.58. What is the ratio of the Gross enrolment ratio (%) in Chile in 2002 to that in 2006?
Provide a succinct answer. 0.94. What is the ratio of the Gross enrolment ratio (%) of Macao in 2002 to that in 2006?
Make the answer very short. 0.85. What is the ratio of the Gross enrolment ratio (%) of Uruguay in 2002 to that in 2006?
Offer a terse response. 1.05. What is the ratio of the Gross enrolment ratio (%) of Cambodia in 2002 to that in 2007?
Provide a short and direct response. 0.54. What is the ratio of the Gross enrolment ratio (%) of Chile in 2002 to that in 2007?
Your answer should be very brief. 0.95. What is the ratio of the Gross enrolment ratio (%) of Macao in 2002 to that in 2007?
Ensure brevity in your answer.  0.89. What is the ratio of the Gross enrolment ratio (%) of Uruguay in 2002 to that in 2007?
Ensure brevity in your answer.  1.15. What is the ratio of the Gross enrolment ratio (%) of Cambodia in 2002 to that in 2008?
Your response must be concise. 0.5. What is the ratio of the Gross enrolment ratio (%) of Chile in 2002 to that in 2008?
Your answer should be very brief. 0.95. What is the ratio of the Gross enrolment ratio (%) of Macao in 2002 to that in 2008?
Ensure brevity in your answer.  0.97. What is the ratio of the Gross enrolment ratio (%) in Uruguay in 2002 to that in 2008?
Provide a short and direct response. 1.21. What is the ratio of the Gross enrolment ratio (%) of Cambodia in 2003 to that in 2004?
Provide a succinct answer. 0.88. What is the ratio of the Gross enrolment ratio (%) of Chile in 2003 to that in 2004?
Keep it short and to the point. 0.99. What is the ratio of the Gross enrolment ratio (%) in Macao in 2003 to that in 2004?
Keep it short and to the point. 0.94. What is the ratio of the Gross enrolment ratio (%) of Uruguay in 2003 to that in 2004?
Offer a very short reply. 1.02. What is the ratio of the Gross enrolment ratio (%) in Cambodia in 2003 to that in 2006?
Give a very brief answer. 0.69. What is the ratio of the Gross enrolment ratio (%) of Chile in 2003 to that in 2006?
Ensure brevity in your answer.  0.97. What is the ratio of the Gross enrolment ratio (%) of Macao in 2003 to that in 2006?
Make the answer very short. 0.9. What is the ratio of the Gross enrolment ratio (%) in Uruguay in 2003 to that in 2006?
Make the answer very short. 1.08. What is the ratio of the Gross enrolment ratio (%) of Cambodia in 2003 to that in 2007?
Keep it short and to the point. 0.64. What is the ratio of the Gross enrolment ratio (%) of Chile in 2003 to that in 2007?
Make the answer very short. 0.98. What is the ratio of the Gross enrolment ratio (%) in Macao in 2003 to that in 2007?
Make the answer very short. 0.94. What is the ratio of the Gross enrolment ratio (%) in Uruguay in 2003 to that in 2007?
Your answer should be compact. 1.19. What is the ratio of the Gross enrolment ratio (%) in Cambodia in 2003 to that in 2008?
Your answer should be very brief. 0.61. What is the ratio of the Gross enrolment ratio (%) of Chile in 2003 to that in 2008?
Your answer should be very brief. 0.98. What is the ratio of the Gross enrolment ratio (%) in Macao in 2003 to that in 2008?
Your response must be concise. 1.03. What is the ratio of the Gross enrolment ratio (%) in Uruguay in 2003 to that in 2008?
Your response must be concise. 1.24. What is the ratio of the Gross enrolment ratio (%) of Cambodia in 2004 to that in 2006?
Give a very brief answer. 0.79. What is the ratio of the Gross enrolment ratio (%) in Chile in 2004 to that in 2006?
Give a very brief answer. 0.98. What is the ratio of the Gross enrolment ratio (%) in Macao in 2004 to that in 2006?
Make the answer very short. 0.96. What is the ratio of the Gross enrolment ratio (%) in Uruguay in 2004 to that in 2006?
Give a very brief answer. 1.06. What is the ratio of the Gross enrolment ratio (%) of Cambodia in 2004 to that in 2007?
Offer a very short reply. 0.74. What is the ratio of the Gross enrolment ratio (%) in Uruguay in 2004 to that in 2007?
Your answer should be very brief. 1.16. What is the ratio of the Gross enrolment ratio (%) in Cambodia in 2004 to that in 2008?
Ensure brevity in your answer.  0.69. What is the ratio of the Gross enrolment ratio (%) in Chile in 2004 to that in 2008?
Make the answer very short. 0.99. What is the ratio of the Gross enrolment ratio (%) in Macao in 2004 to that in 2008?
Keep it short and to the point. 1.09. What is the ratio of the Gross enrolment ratio (%) of Uruguay in 2004 to that in 2008?
Offer a terse response. 1.22. What is the ratio of the Gross enrolment ratio (%) of Cambodia in 2006 to that in 2007?
Keep it short and to the point. 0.93. What is the ratio of the Gross enrolment ratio (%) of Chile in 2006 to that in 2007?
Your answer should be very brief. 1.01. What is the ratio of the Gross enrolment ratio (%) in Macao in 2006 to that in 2007?
Give a very brief answer. 1.04. What is the ratio of the Gross enrolment ratio (%) of Uruguay in 2006 to that in 2007?
Provide a short and direct response. 1.1. What is the ratio of the Gross enrolment ratio (%) of Cambodia in 2006 to that in 2008?
Keep it short and to the point. 0.88. What is the ratio of the Gross enrolment ratio (%) of Chile in 2006 to that in 2008?
Your response must be concise. 1.01. What is the ratio of the Gross enrolment ratio (%) of Macao in 2006 to that in 2008?
Keep it short and to the point. 1.14. What is the ratio of the Gross enrolment ratio (%) of Uruguay in 2006 to that in 2008?
Your answer should be compact. 1.15. What is the ratio of the Gross enrolment ratio (%) of Cambodia in 2007 to that in 2008?
Your answer should be very brief. 0.94. What is the ratio of the Gross enrolment ratio (%) in Chile in 2007 to that in 2008?
Provide a succinct answer. 1. What is the ratio of the Gross enrolment ratio (%) in Macao in 2007 to that in 2008?
Offer a very short reply. 1.09. What is the ratio of the Gross enrolment ratio (%) in Uruguay in 2007 to that in 2008?
Your answer should be compact. 1.05. What is the difference between the highest and the second highest Gross enrolment ratio (%) in Cambodia?
Make the answer very short. 2.64. What is the difference between the highest and the second highest Gross enrolment ratio (%) in Chile?
Your answer should be compact. 0.75. What is the difference between the highest and the second highest Gross enrolment ratio (%) of Macao?
Ensure brevity in your answer.  4.26. What is the difference between the highest and the second highest Gross enrolment ratio (%) in Uruguay?
Your answer should be compact. 2.12. What is the difference between the highest and the lowest Gross enrolment ratio (%) of Cambodia?
Offer a terse response. 28.01. What is the difference between the highest and the lowest Gross enrolment ratio (%) in Chile?
Offer a very short reply. 8.27. What is the difference between the highest and the lowest Gross enrolment ratio (%) in Macao?
Offer a terse response. 24.48. What is the difference between the highest and the lowest Gross enrolment ratio (%) of Uruguay?
Your answer should be compact. 21.4. 